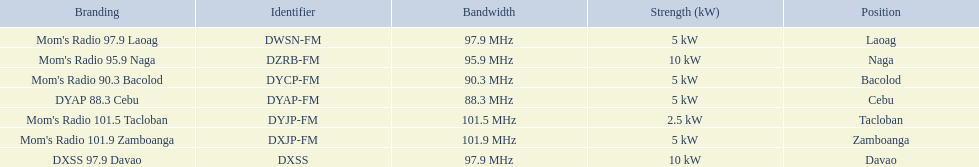Which stations broadcast in dyap-fm? Mom's Radio 97.9 Laoag, Mom's Radio 95.9 Naga, Mom's Radio 90.3 Bacolod, DYAP 88.3 Cebu, Mom's Radio 101.5 Tacloban, Mom's Radio 101.9 Zamboanga, DXSS 97.9 Davao. Of those stations which broadcast in dyap-fm, which stations broadcast with 5kw of power or under? Mom's Radio 97.9 Laoag, Mom's Radio 90.3 Bacolod, DYAP 88.3 Cebu, Mom's Radio 101.5 Tacloban, Mom's Radio 101.9 Zamboanga. Of those stations that broadcast with 5kw of power or under, which broadcasts with the least power? Mom's Radio 101.5 Tacloban. 